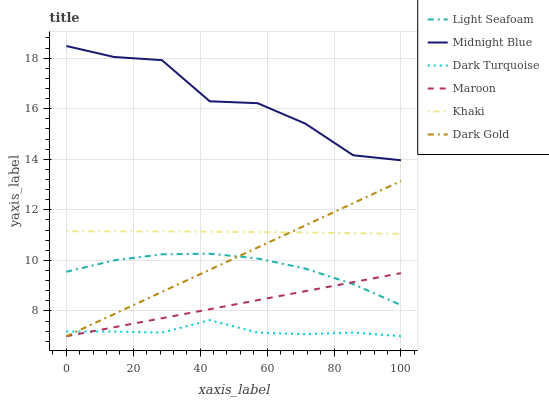Does Dark Gold have the minimum area under the curve?
Answer yes or no. No. Does Dark Gold have the maximum area under the curve?
Answer yes or no. No. Is Midnight Blue the smoothest?
Answer yes or no. No. Is Dark Gold the roughest?
Answer yes or no. No. Does Midnight Blue have the lowest value?
Answer yes or no. No. Does Dark Gold have the highest value?
Answer yes or no. No. Is Light Seafoam less than Midnight Blue?
Answer yes or no. Yes. Is Khaki greater than Maroon?
Answer yes or no. Yes. Does Light Seafoam intersect Midnight Blue?
Answer yes or no. No. 